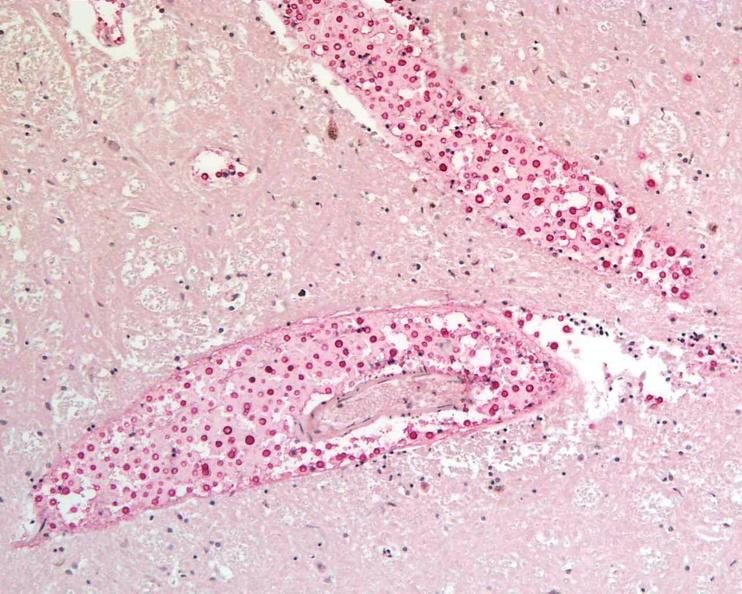do seminoma stain?
Answer the question using a single word or phrase. No 